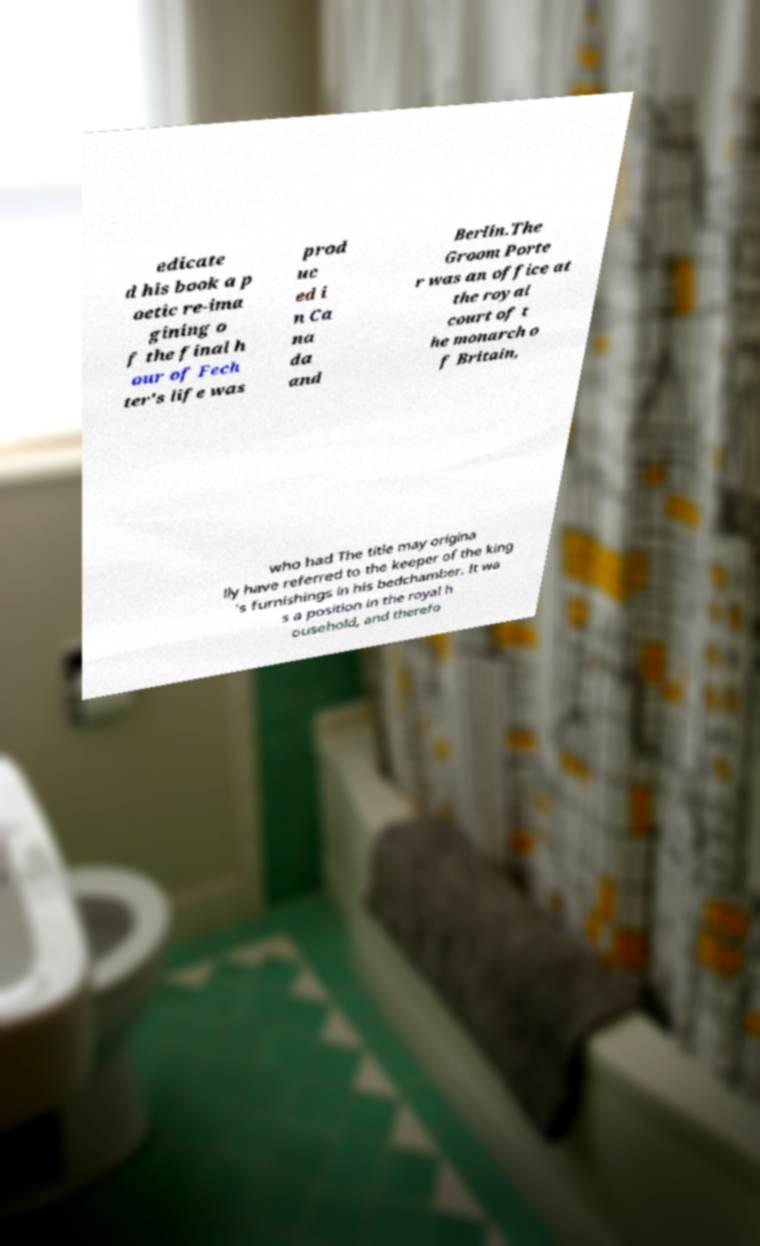I need the written content from this picture converted into text. Can you do that? edicate d his book a p oetic re-ima gining o f the final h our of Fech ter's life was prod uc ed i n Ca na da and Berlin.The Groom Porte r was an office at the royal court of t he monarch o f Britain, who had The title may origina lly have referred to the keeper of the king 's furnishings in his bedchamber. It wa s a position in the royal h ousehold, and therefo 